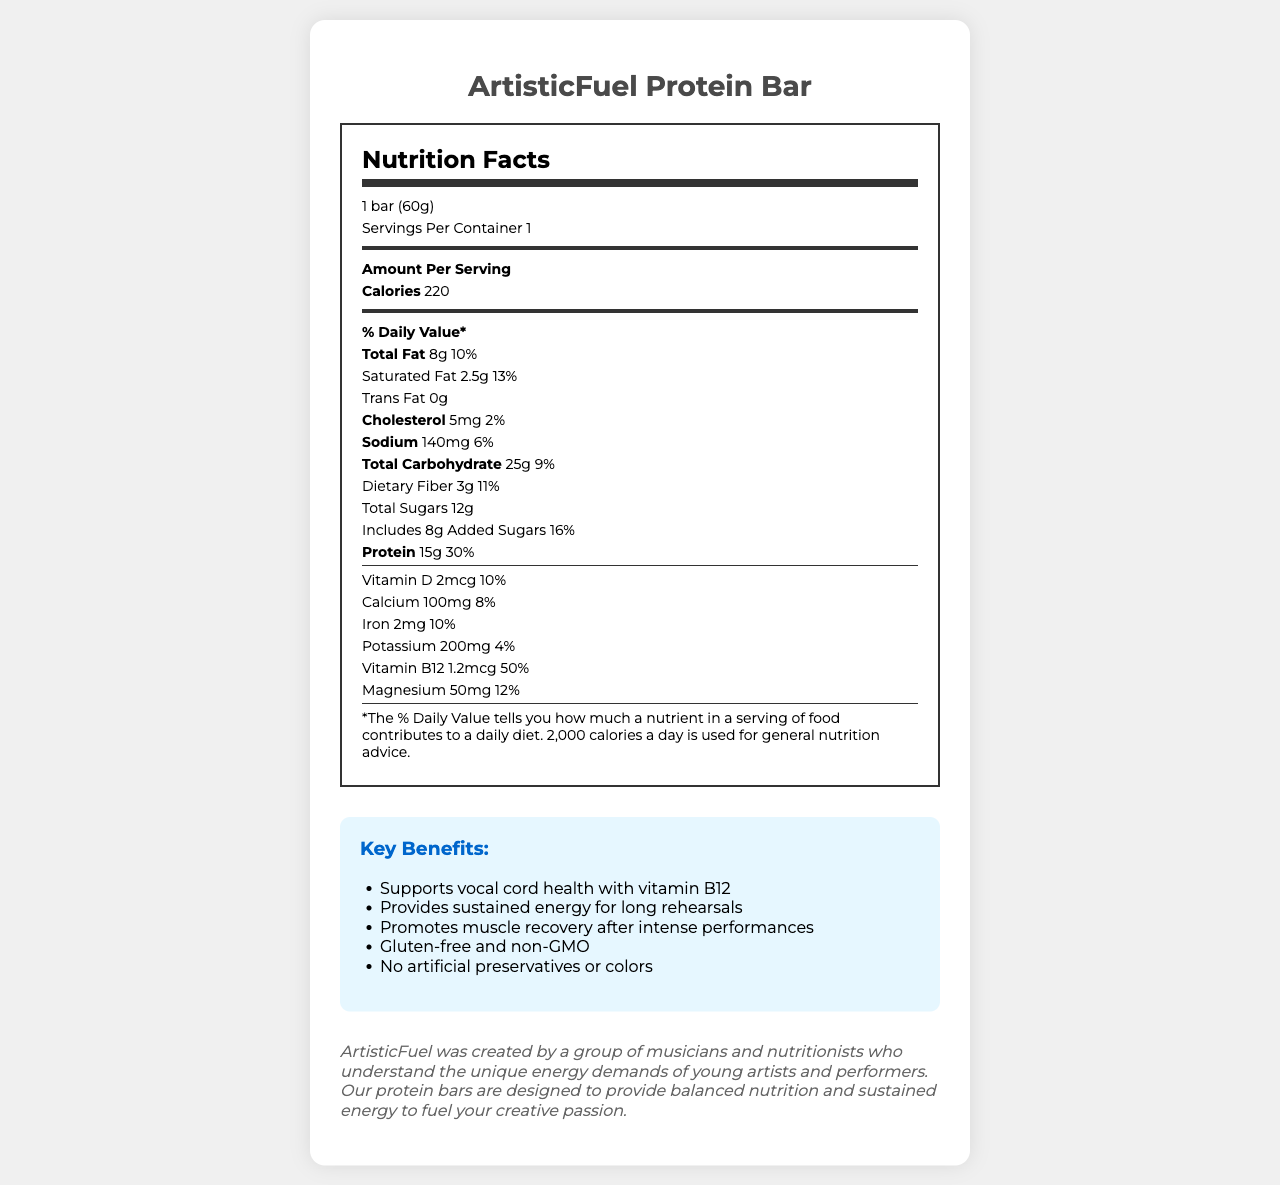What is the serving size of the ArtisticFuel Protein Bar? The serving size is specified at the top of the Nutrition Facts section.
Answer: 1 bar (60g) How many calories are in one serving of the ArtisticFuel Protein Bar? The document states the calories per serving directly after the "Amount Per Serving" heading.
Answer: 220 calories What is the percentage daily value of Vitamin B12 in the ArtisticFuel Protein Bar? The percentage daily value of Vitamin B12 is listed under the nutrients section.
Answer: 50% How much saturated fat is in the ArtisticFuel Protein Bar? The amount of saturated fat is detailed under the Total Fat subsection.
Answer: 2.5g What allergens are contained in the ArtisticFuel Protein Bar? The allergens are listed at the bottom of the nutrient details section.
Answer: Contains milk and tree nuts (almonds); May contain traces of soy and peanuts What is the main carbohydrate source in the ArtisticFuel Protein Bar? A. Whey protein isolate B. Brown rice syrup C. Almonds D. Dried cranberries Brown rice syrup is listed first among the ingredients, indicating it is a major component and primary carbohydrate source.
Answer: B. Brown rice syrup Which marketing claim suggests the bar helps with muscle recovery? A. Supports vocal cord health B. Promotes muscle recovery after intense performances C. Provides sustained energy for long rehearsals The specific claim "Promotes muscle recovery after intense performances" addresses this benefit.
Answer: B. Promotes muscle recovery after intense performances Is the ArtisticFuel Protein Bar gluten-free? The claim "Gluten-free and non-GMO" can be found within the marketing claims section.
Answer: Yes Summarize the main intent of the document. The document is intended to inform consumers, particularly young artists, about the nutritional value and benefits of the ArtisticFuel Protein Bar, including its support for energy, muscle recovery, and vocal cord health.
Answer: The document provides nutritional information and marketing benefits for the ArtisticFuel Protein Bar, highlighting its balanced nutrition tailored to young artists and performers. It includes detailed nutrient content, ingredient list, allergens, health benefits, and the brand's story. What are the exact amounts of dietary fiber and total sugars in the bar? The amounts are specified under the Total Carbohydrate section.
Answer: Dietary Fiber: 3g, Total Sugars: 12g What flavors are included in the ArtisticFuel Protein Bar? The document lists "Natural flavors" as an ingredient but does not provide details on specific flavors.
Answer: Not enough information How much protein does the ArtisticFuel Protein Bar provide? The protein content is listed clearly within the nutrient facts section.
Answer: 15g What is the ingredient used for the primary protein source in the ArtisticFuel Protein Bar? A. Almonds B. Pea protein crisps C. Whey protein isolate D. Sunflower seed butter Whey protein isolate is listed first among the ingredients, indicating it is the primary protein source.
Answer: C. Whey protein isolate What percentage of the daily value of calcium does the ArtisticFuel Protein Bar provide? The calcium content and its daily value percentage are listed within the Vitamins and Minerals section.
Answer: 8% 